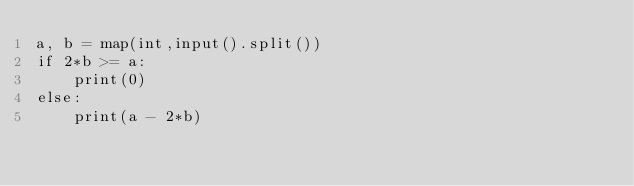Convert code to text. <code><loc_0><loc_0><loc_500><loc_500><_Python_>a, b = map(int,input().split())
if 2*b >= a:
    print(0)
else:
    print(a - 2*b)
</code> 